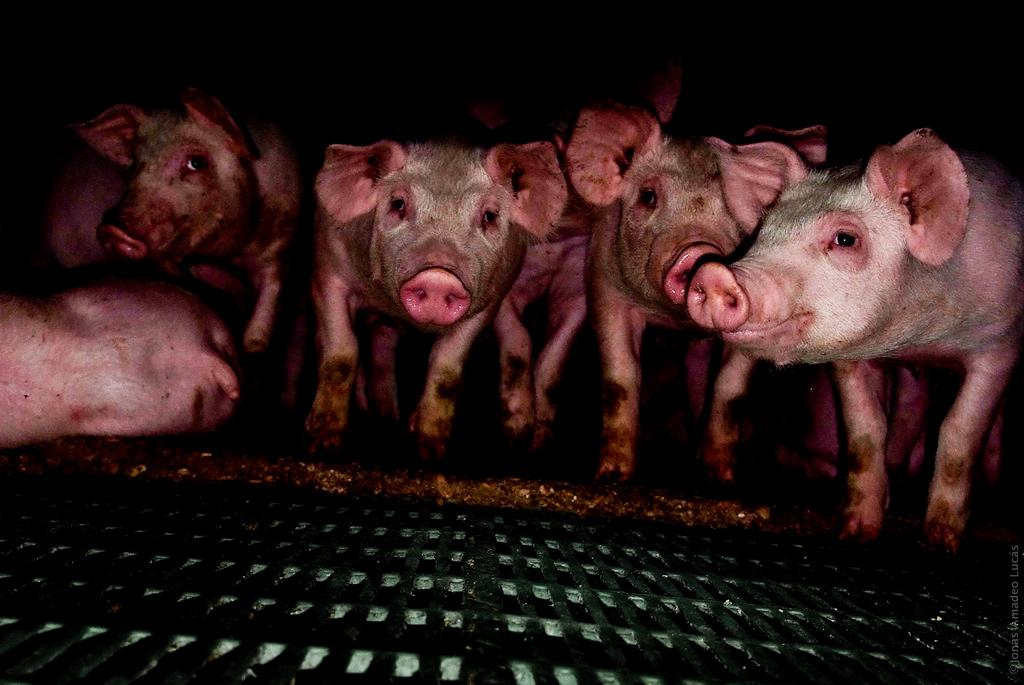What animals are present in the image? There are many pigs in the image. Where are the pigs located? The pigs are on a hole. What material is at the bottom of the hole? There is a steel plate at the bottom of the hole. What advice does the grandmother give to the pigs in the image? There is no grandmother present in the image, so it is not possible to answer that question. 